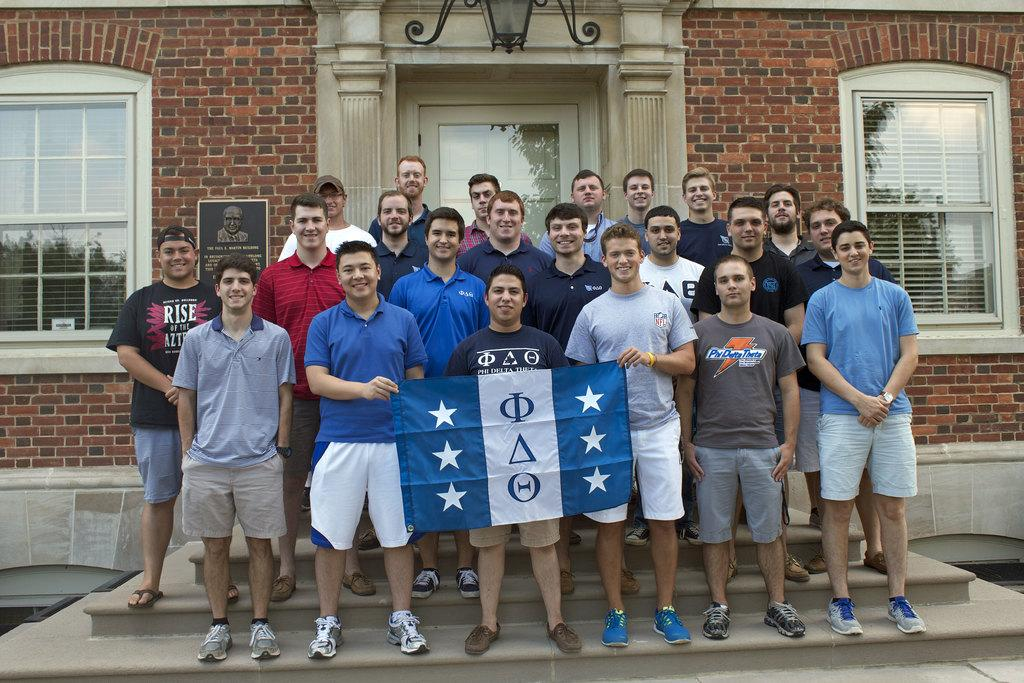What are the people in the image doing? The people in the image are standing on the staircase. What can be seen flying in the image? There is a flag in the image. What is visible in the background of the image? There is a building in the background of the image. What type of material is used for the windows in the image? There are glass windows visible in the image. What type of game is being played on the staircase in the image? There is no game being played in the image; the people are simply standing on the staircase. 